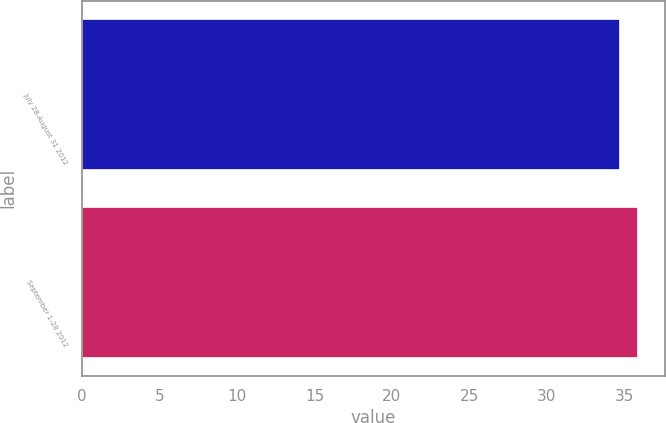Convert chart. <chart><loc_0><loc_0><loc_500><loc_500><bar_chart><fcel>July 28-August 31 2012<fcel>September 1-28 2012<nl><fcel>34.63<fcel>35.81<nl></chart> 